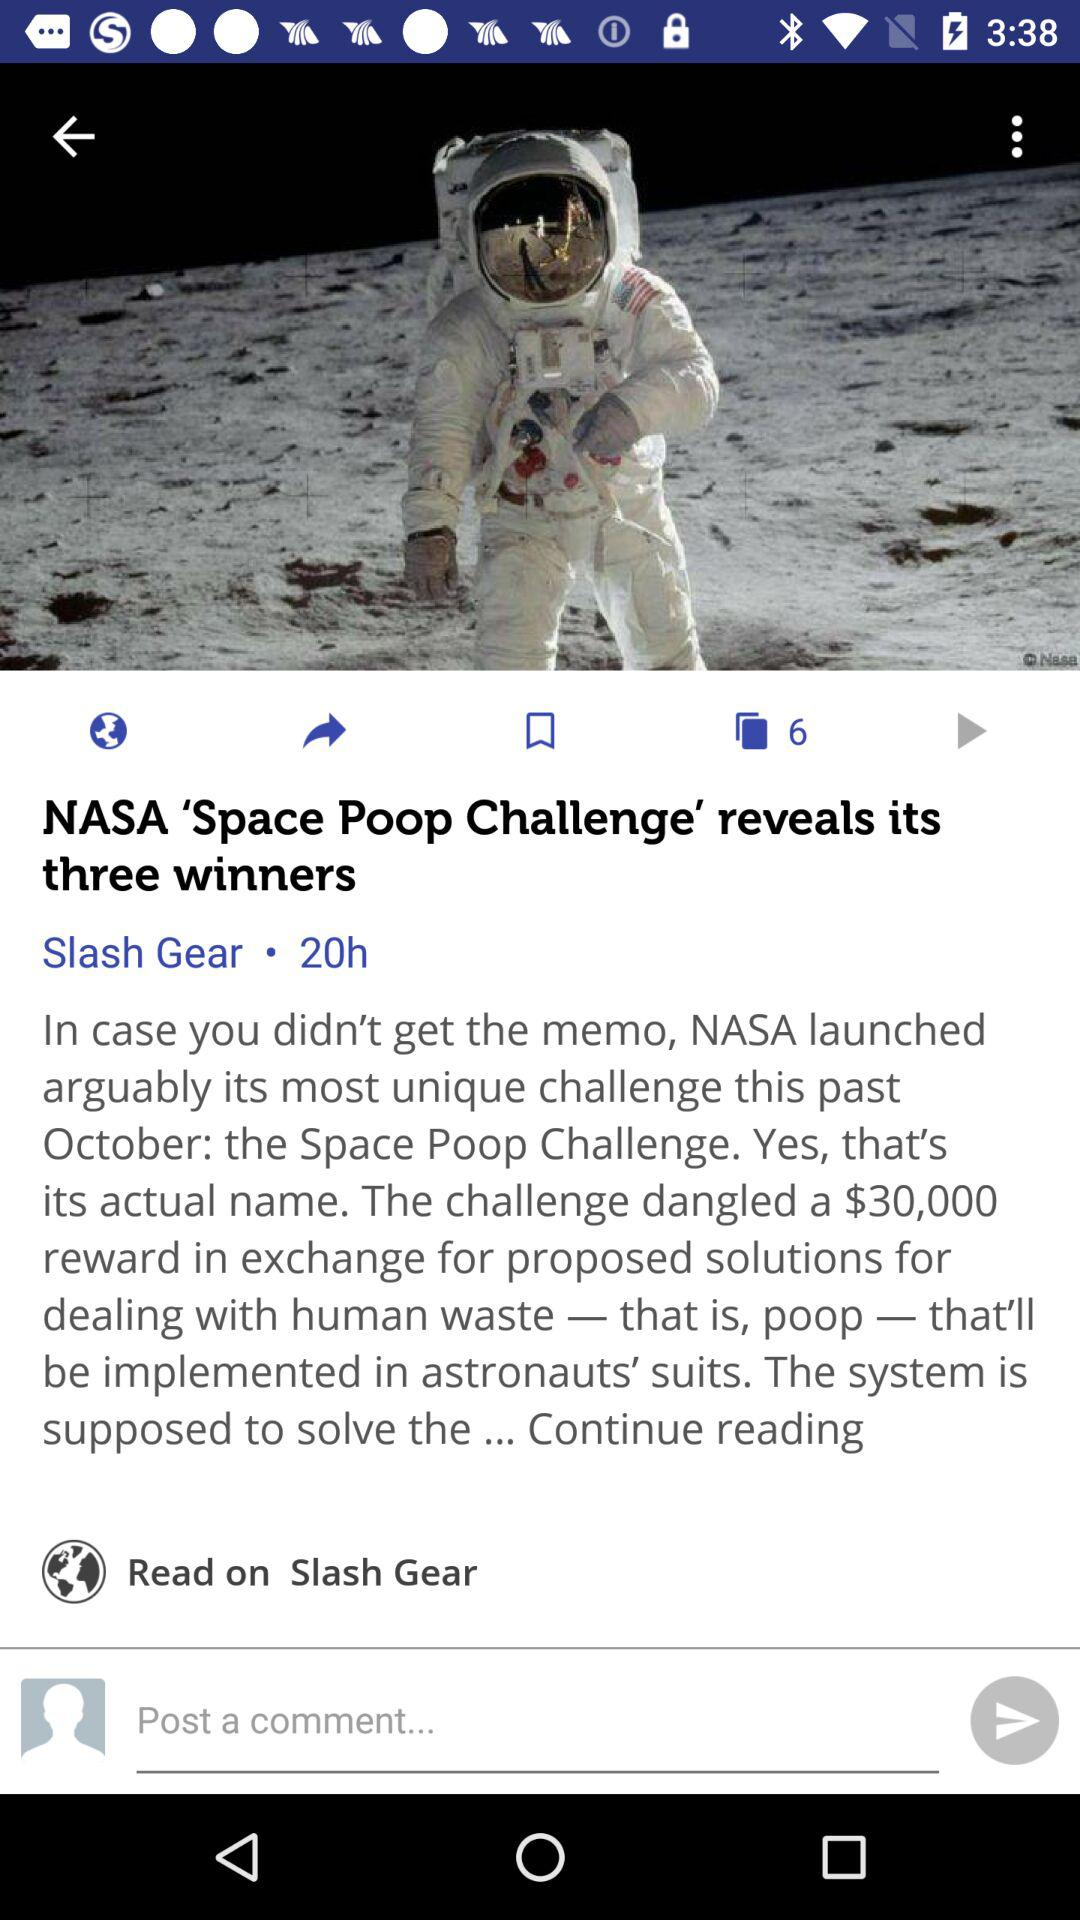When was the post updated? The post was updated 20 hours ago. 